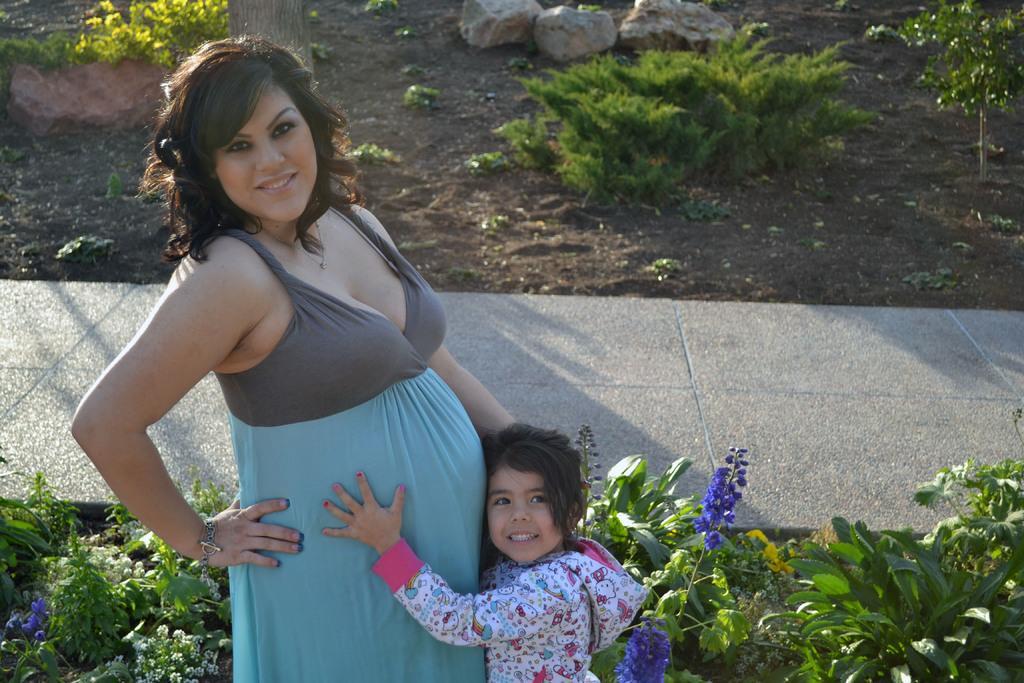Please provide a concise description of this image. In this picture there is a woman standing and smiling and there is a girl standing. At the back there are plants and rocks and there is a pavement and there is mud. In the foreground there are violet flowers and white flowers on the plants. 